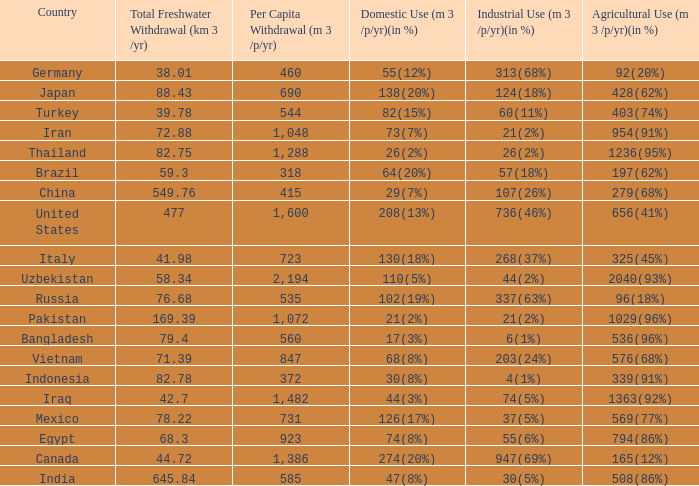What is the highest Per Capita Withdrawal (m 3 /p/yr), when Agricultural Use (m 3 /p/yr)(in %) is 1363(92%), and when Total Freshwater Withdrawal (km 3 /yr) is less than 42.7? None. I'm looking to parse the entire table for insights. Could you assist me with that? {'header': ['Country', 'Total Freshwater Withdrawal (km 3 /yr)', 'Per Capita Withdrawal (m 3 /p/yr)', 'Domestic Use (m 3 /p/yr)(in %)', 'Industrial Use (m 3 /p/yr)(in %)', 'Agricultural Use (m 3 /p/yr)(in %)'], 'rows': [['Germany', '38.01', '460', '55(12%)', '313(68%)', '92(20%)'], ['Japan', '88.43', '690', '138(20%)', '124(18%)', '428(62%)'], ['Turkey', '39.78', '544', '82(15%)', '60(11%)', '403(74%)'], ['Iran', '72.88', '1,048', '73(7%)', '21(2%)', '954(91%)'], ['Thailand', '82.75', '1,288', '26(2%)', '26(2%)', '1236(95%)'], ['Brazil', '59.3', '318', '64(20%)', '57(18%)', '197(62%)'], ['China', '549.76', '415', '29(7%)', '107(26%)', '279(68%)'], ['United States', '477', '1,600', '208(13%)', '736(46%)', '656(41%)'], ['Italy', '41.98', '723', '130(18%)', '268(37%)', '325(45%)'], ['Uzbekistan', '58.34', '2,194', '110(5%)', '44(2%)', '2040(93%)'], ['Russia', '76.68', '535', '102(19%)', '337(63%)', '96(18%)'], ['Pakistan', '169.39', '1,072', '21(2%)', '21(2%)', '1029(96%)'], ['Bangladesh', '79.4', '560', '17(3%)', '6(1%)', '536(96%)'], ['Vietnam', '71.39', '847', '68(8%)', '203(24%)', '576(68%)'], ['Indonesia', '82.78', '372', '30(8%)', '4(1%)', '339(91%)'], ['Iraq', '42.7', '1,482', '44(3%)', '74(5%)', '1363(92%)'], ['Mexico', '78.22', '731', '126(17%)', '37(5%)', '569(77%)'], ['Egypt', '68.3', '923', '74(8%)', '55(6%)', '794(86%)'], ['Canada', '44.72', '1,386', '274(20%)', '947(69%)', '165(12%)'], ['India', '645.84', '585', '47(8%)', '30(5%)', '508(86%)']]} 